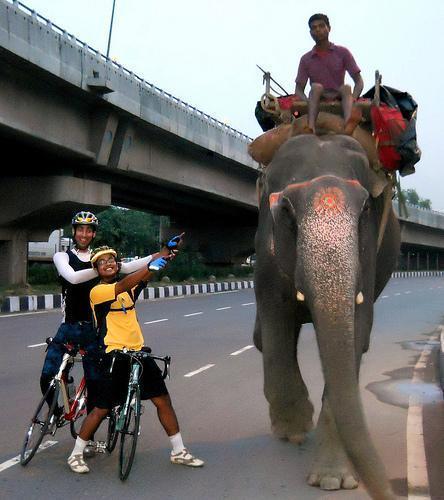How many people are riding an elephant?
Give a very brief answer. 1. 